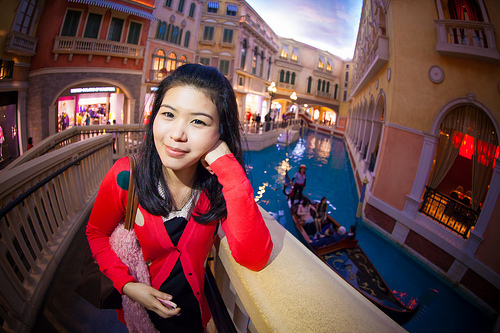<image>
Is the building behind the girl? Yes. From this viewpoint, the building is positioned behind the girl, with the girl partially or fully occluding the building. Where is the girl in relation to the boat? Is it above the boat? No. The girl is not positioned above the boat. The vertical arrangement shows a different relationship. 